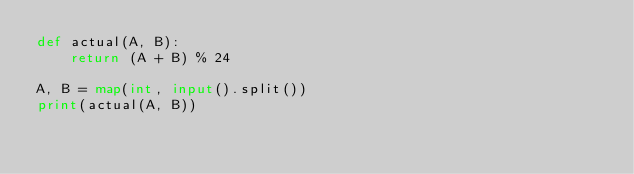<code> <loc_0><loc_0><loc_500><loc_500><_Python_>def actual(A, B):
    return (A + B) % 24

A, B = map(int, input().split())
print(actual(A, B))</code> 